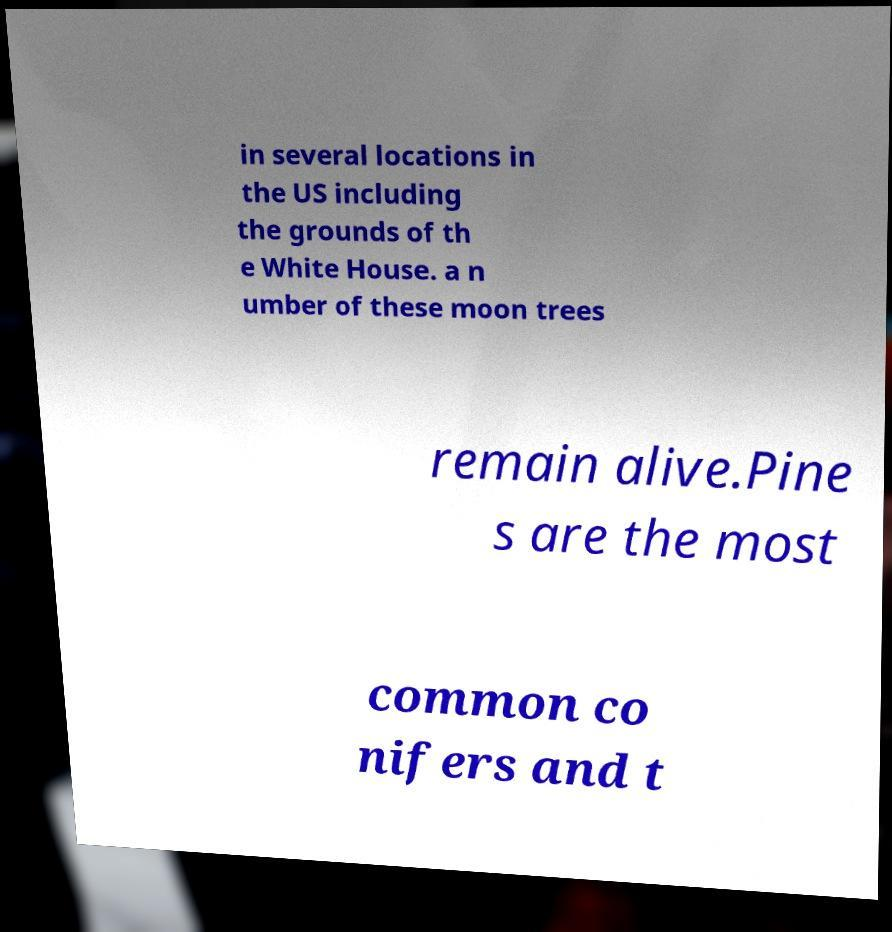Could you extract and type out the text from this image? in several locations in the US including the grounds of th e White House. a n umber of these moon trees remain alive.Pine s are the most common co nifers and t 